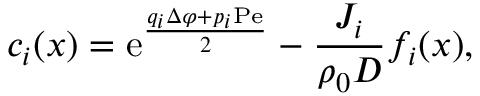Convert formula to latex. <formula><loc_0><loc_0><loc_500><loc_500>c _ { i } ( x ) = e ^ { \frac { q _ { i } \Delta \varphi + p _ { i } P e } { 2 } } - \frac { J _ { i } } { \rho _ { 0 } D } f _ { i } ( x ) ,</formula> 